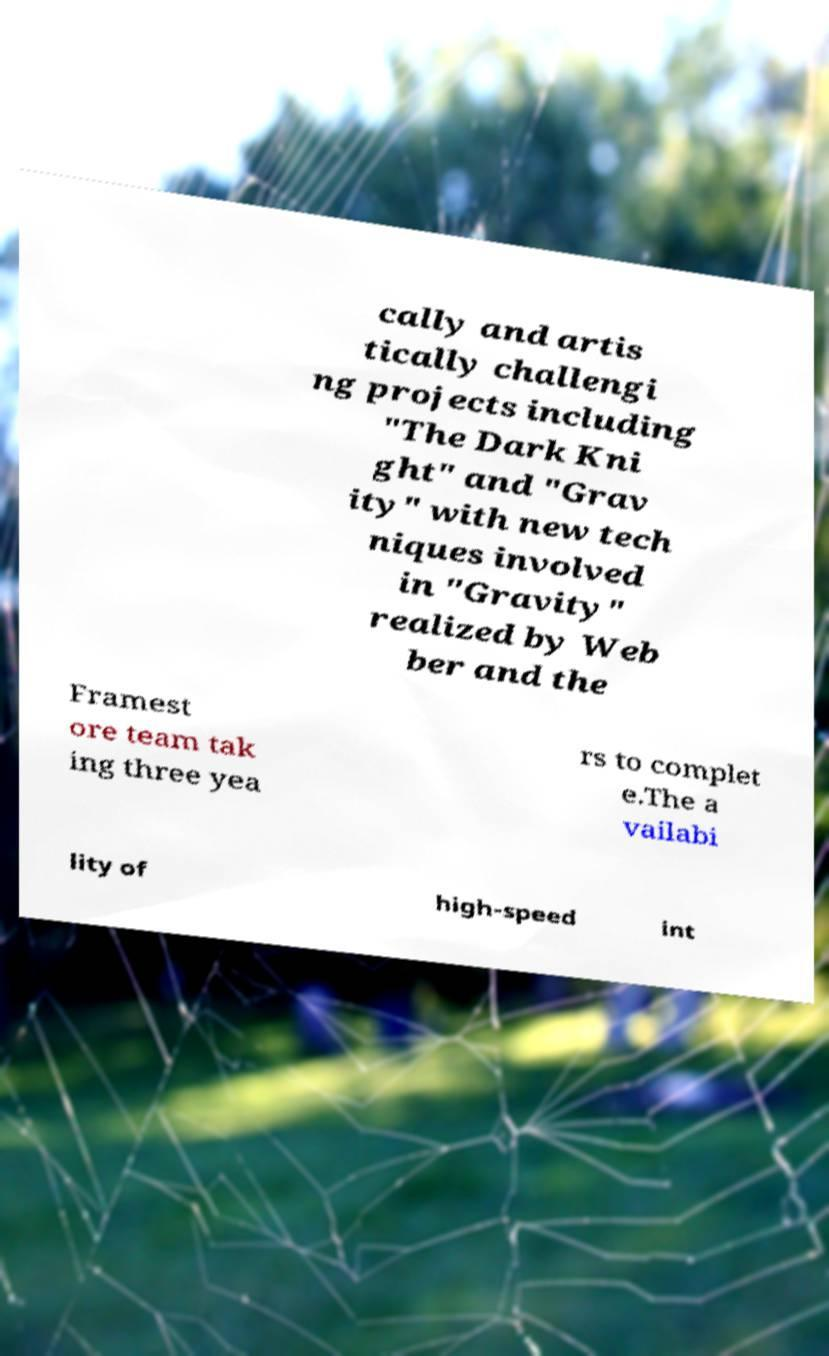What messages or text are displayed in this image? I need them in a readable, typed format. cally and artis tically challengi ng projects including "The Dark Kni ght" and "Grav ity" with new tech niques involved in "Gravity" realized by Web ber and the Framest ore team tak ing three yea rs to complet e.The a vailabi lity of high-speed int 